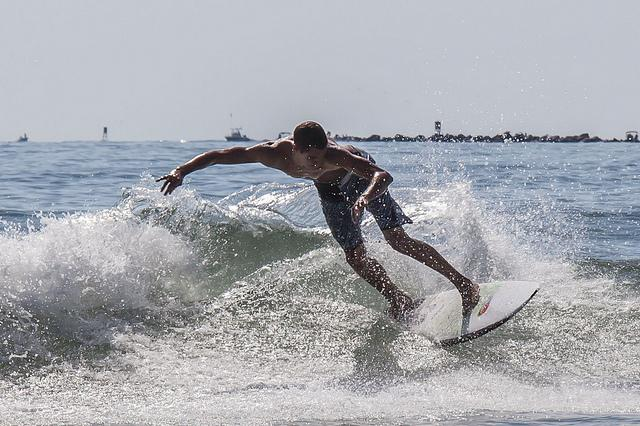Why is he leaning forward?

Choices:
A) is falling
B) maintaining balance
C) was surprised
D) bad back maintaining balance 